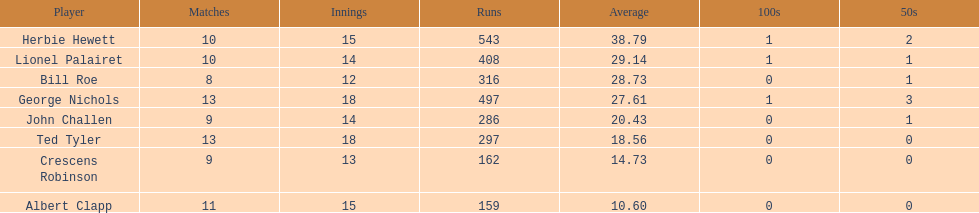What is the smallest number of runs someone holds? 159. 